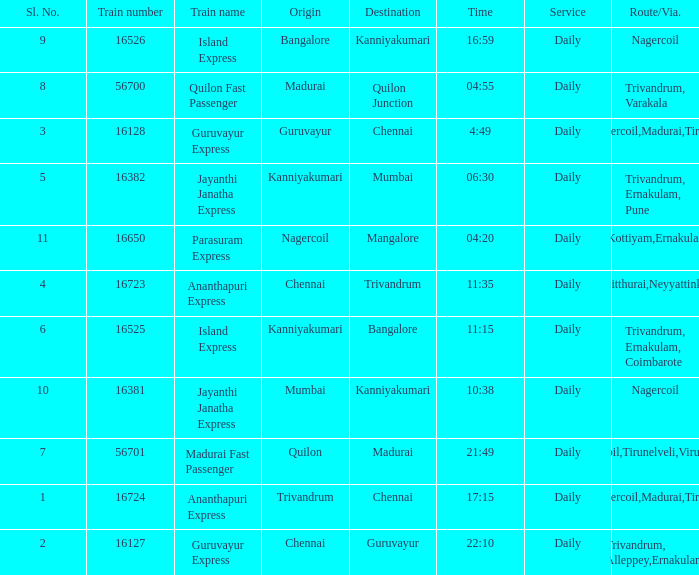What is the origin when the destination is Mumbai? Kanniyakumari. 